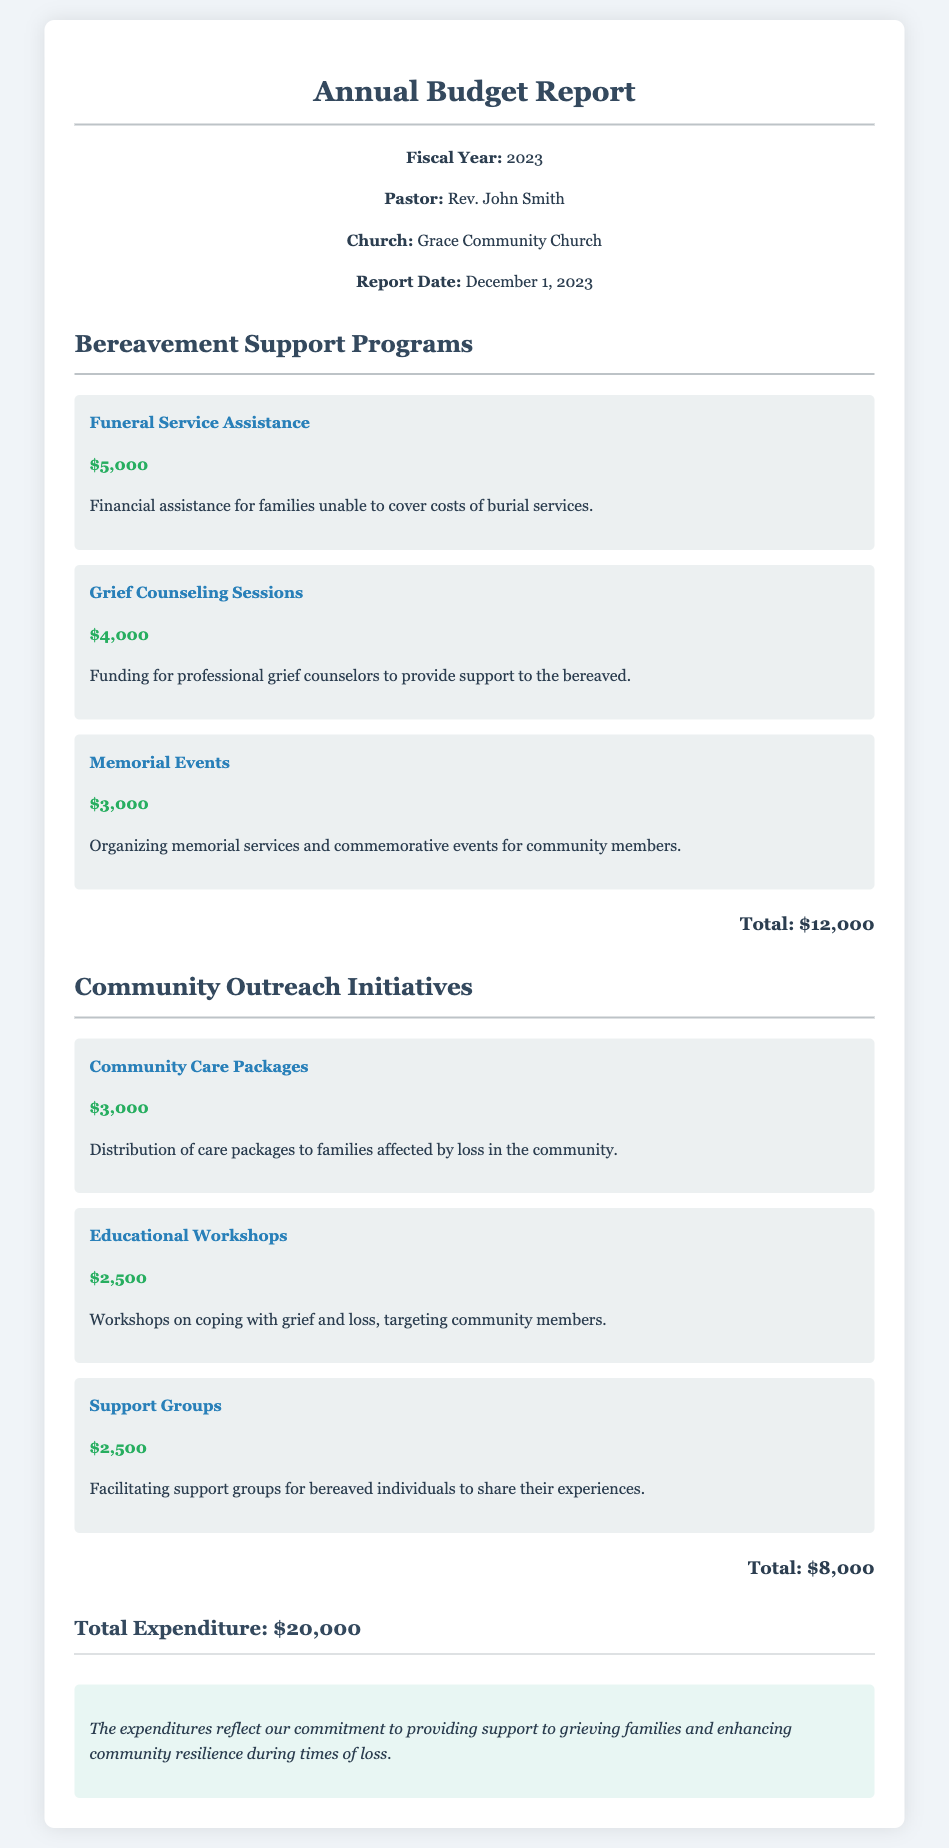What is the fiscal year reported? The fiscal year reported in the document is indicated at the header, stating 2023.
Answer: 2023 What is the total expenditure on Bereavement Support Programs? The total expenditure for this section is shown at the end of the Bereavement Support Programs subsection, which sums to $12,000.
Answer: $12,000 How much was allocated for Grief Counseling Sessions? The document specifies the funding amount for Grief Counseling Sessions as listed under Bereavement Support Programs.
Answer: $4,000 What is the total amount spent on Community Outreach Initiatives? The total for this section is provided at the close of the Community Outreach Initiatives subsection, totaling $8,000.
Answer: $8,000 Who is the pastor mentioned in the report? The name of the pastor can be found in the header information of the report, identifying Rev. John Smith.
Answer: Rev. John Smith What is one type of support provided under Community Outreach Initiatives? The document lists multiple initiatives, one of which is Community Care Packages as a type of support provided.
Answer: Community Care Packages What is the total expenditure of the church for the fiscal year? The overall expenditure is summed up at the bottom of the document, which includes all expenditures listed in both categories.
Answer: $20,000 How much funding was allocated for Memorial Events? The financial contribution for Memorial Events is detailed as part of the Bereavement Support Programs section.
Answer: $3,000 What is the main purpose of the expenditures noted in the remarks? The remarks describe the general intention behind the expenditures, highlighting support for grieving families and community resilience.
Answer: support to grieving families and enhancing community resilience 